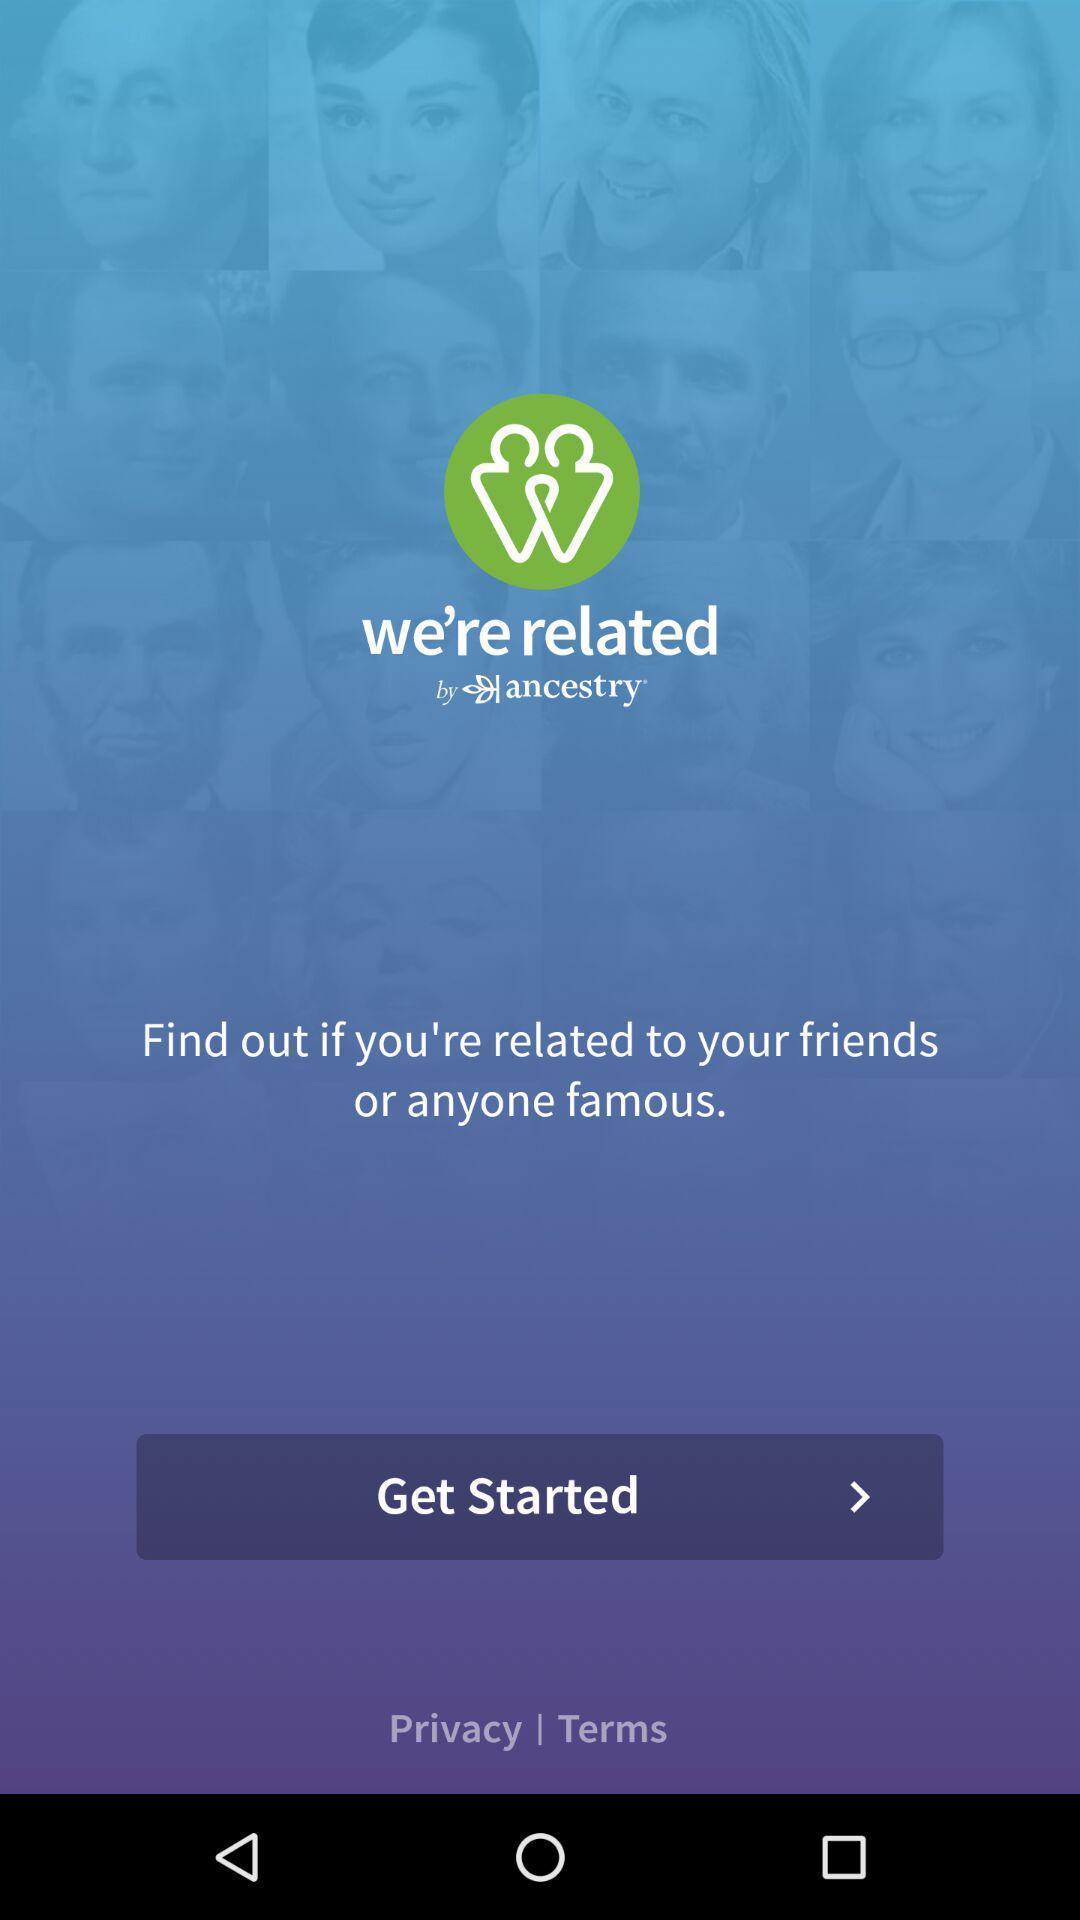Give me a narrative description of this picture. Welcome page to an app. 